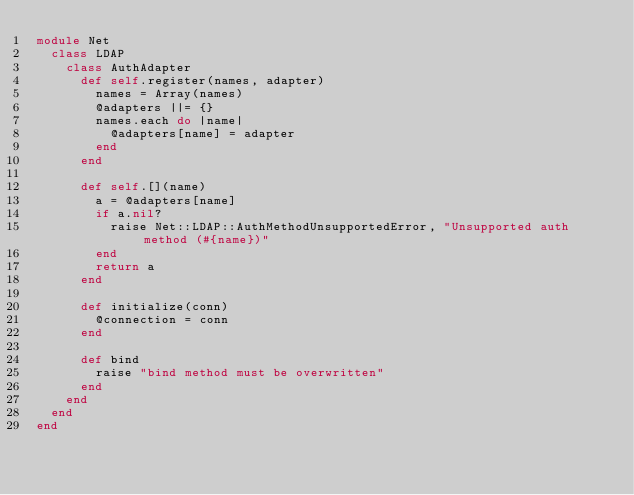Convert code to text. <code><loc_0><loc_0><loc_500><loc_500><_Ruby_>module Net
  class LDAP
    class AuthAdapter
      def self.register(names, adapter)
        names = Array(names)
        @adapters ||= {}
        names.each do |name|
          @adapters[name] = adapter
        end
      end

      def self.[](name)
        a = @adapters[name]
        if a.nil?
          raise Net::LDAP::AuthMethodUnsupportedError, "Unsupported auth method (#{name})"
        end
        return a
      end

      def initialize(conn)
        @connection = conn
      end

      def bind
        raise "bind method must be overwritten"
      end
    end
  end
end
</code> 